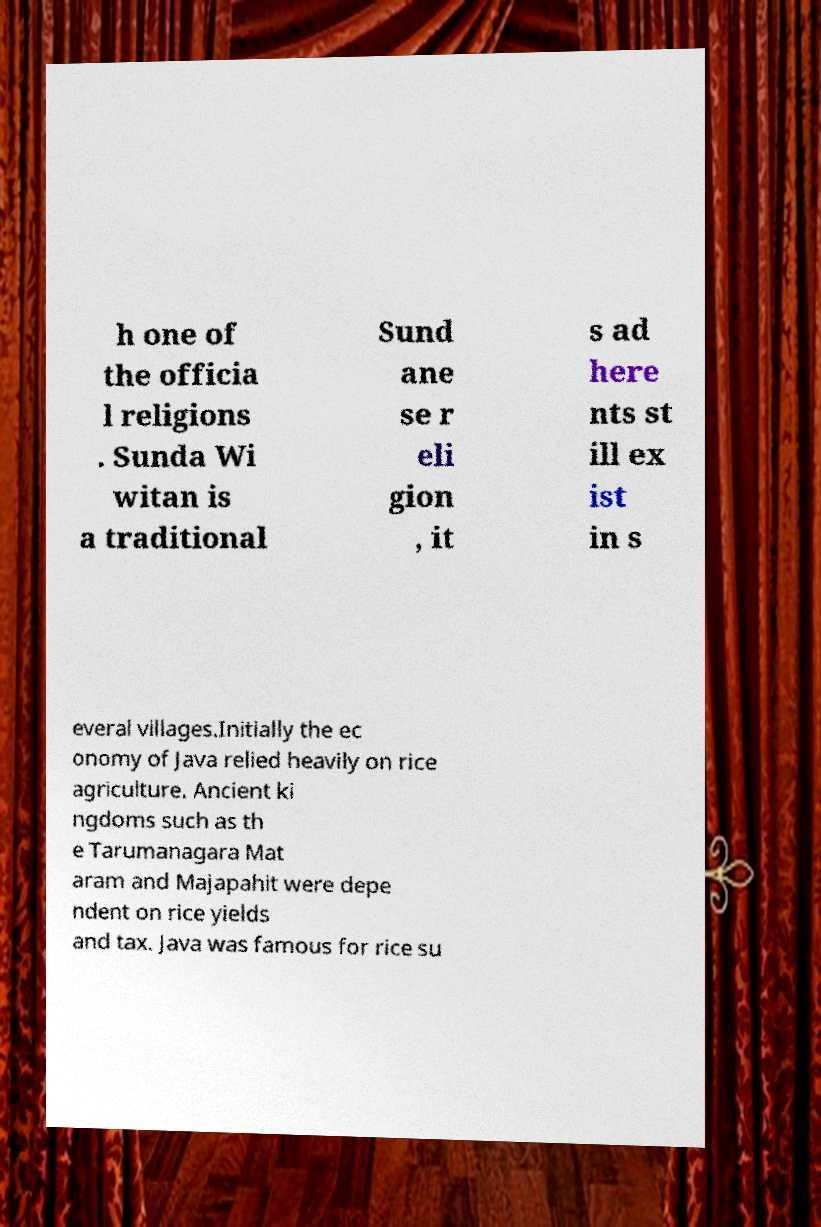Could you extract and type out the text from this image? h one of the officia l religions . Sunda Wi witan is a traditional Sund ane se r eli gion , it s ad here nts st ill ex ist in s everal villages.Initially the ec onomy of Java relied heavily on rice agriculture. Ancient ki ngdoms such as th e Tarumanagara Mat aram and Majapahit were depe ndent on rice yields and tax. Java was famous for rice su 